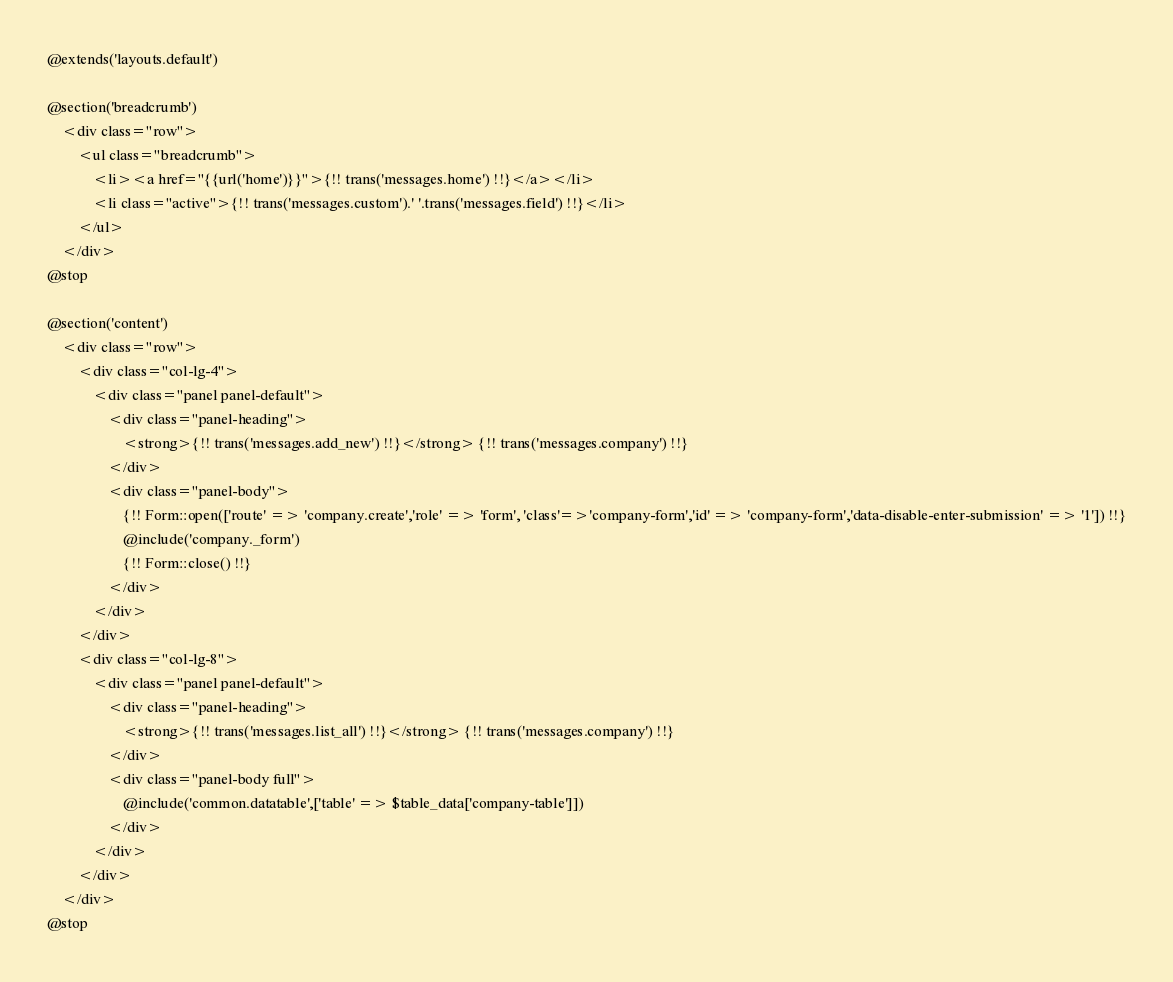<code> <loc_0><loc_0><loc_500><loc_500><_PHP_>@extends('layouts.default')

@section('breadcrumb')
	<div class="row">
		<ul class="breadcrumb">
			<li><a href="{{url('home')}}">{!! trans('messages.home') !!}</a></li>
			<li class="active">{!! trans('messages.custom').' '.trans('messages.field') !!}</li>
		</ul>
	</div>
@stop

@section('content')
	<div class="row">
		<div class="col-lg-4">
			<div class="panel panel-default">
				<div class="panel-heading">
					<strong>{!! trans('messages.add_new') !!}</strong> {!! trans('messages.company') !!}
				</div>
				<div class="panel-body">
					{!! Form::open(['route' => 'company.create','role' => 'form', 'class'=>'company-form','id' => 'company-form','data-disable-enter-submission' => '1']) !!}
					@include('company._form')
					{!! Form::close() !!}
				</div>
			</div>
		</div>
		<div class="col-lg-8">
			<div class="panel panel-default">
				<div class="panel-heading">
					<strong>{!! trans('messages.list_all') !!}</strong> {!! trans('messages.company') !!}
				</div>
				<div class="panel-body full">
					@include('common.datatable',['table' => $table_data['company-table']])
				</div>
			</div>
		</div>
	</div>
@stop</code> 